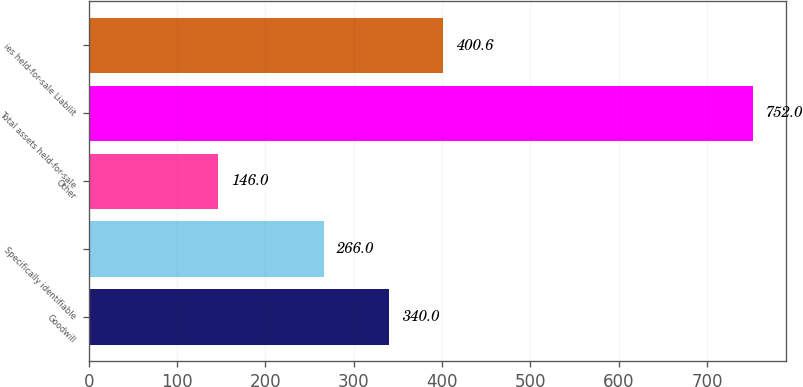Convert chart. <chart><loc_0><loc_0><loc_500><loc_500><bar_chart><fcel>Goodwill<fcel>Specifically identifiable<fcel>Other<fcel>Total assets held-for-sale<fcel>ies held-for-sale Liabilit<nl><fcel>340<fcel>266<fcel>146<fcel>752<fcel>400.6<nl></chart> 